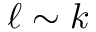<formula> <loc_0><loc_0><loc_500><loc_500>\ell \sim k</formula> 